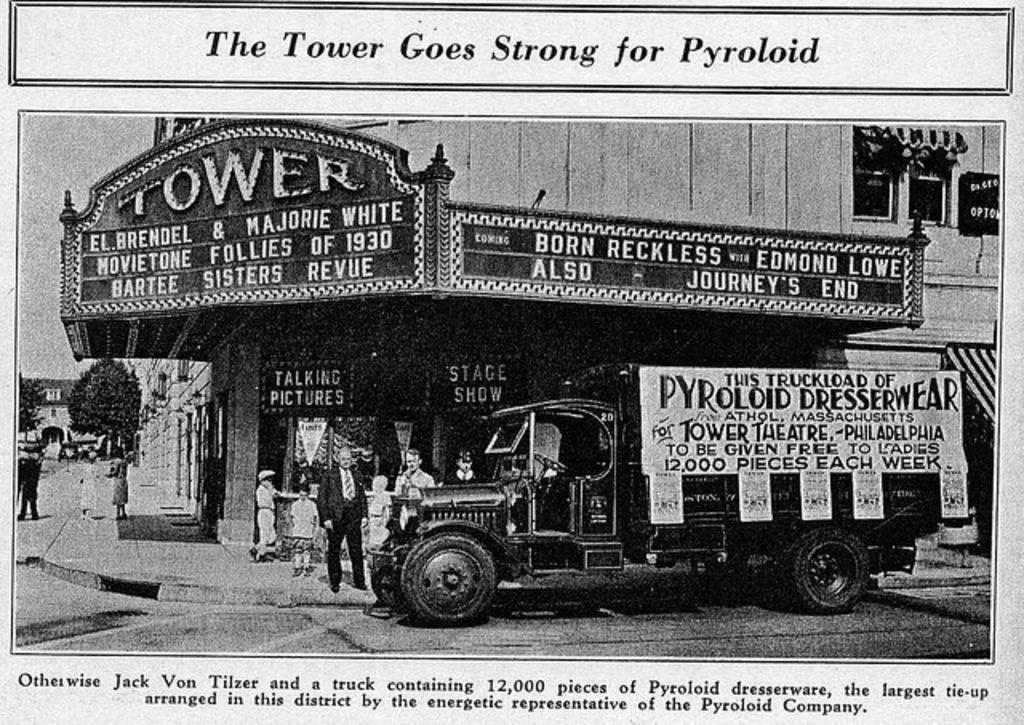What type of structure is visible in the image? There is a building in the image. What objects are present near the building? There are boards and trees visible in the image. What mode of transportation can be seen in the image? There is a vehicle in the image. Are there any people in the image? Yes, there are persons in the image. Is there any text present in the image? Yes, there is text written in the image. Can you describe the suit that the stranger is wearing in the image? There is no stranger present in the image, and therefore no suit can be described. What type of hammer is being used by the person in the image? There is no hammer present in the image. 